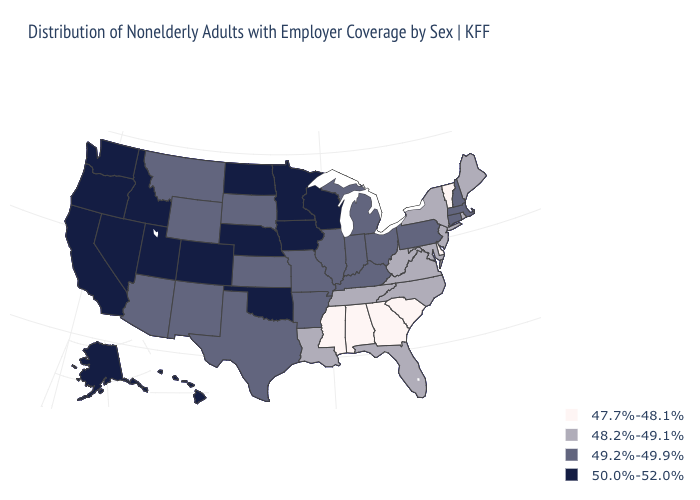Does Missouri have the lowest value in the MidWest?
Short answer required. Yes. What is the value of Minnesota?
Write a very short answer. 50.0%-52.0%. Name the states that have a value in the range 50.0%-52.0%?
Quick response, please. Alaska, California, Colorado, Hawaii, Idaho, Iowa, Minnesota, Nebraska, Nevada, North Dakota, Oklahoma, Oregon, Utah, Washington, Wisconsin. What is the value of Michigan?
Keep it brief. 49.2%-49.9%. What is the highest value in states that border Louisiana?
Be succinct. 49.2%-49.9%. Name the states that have a value in the range 47.7%-48.1%?
Keep it brief. Alabama, Delaware, Georgia, Mississippi, South Carolina, Vermont. Among the states that border Idaho , which have the lowest value?
Quick response, please. Montana, Wyoming. What is the lowest value in the South?
Answer briefly. 47.7%-48.1%. Which states have the highest value in the USA?
Short answer required. Alaska, California, Colorado, Hawaii, Idaho, Iowa, Minnesota, Nebraska, Nevada, North Dakota, Oklahoma, Oregon, Utah, Washington, Wisconsin. Name the states that have a value in the range 48.2%-49.1%?
Give a very brief answer. Florida, Louisiana, Maine, Maryland, New Jersey, New York, North Carolina, Rhode Island, Tennessee, Virginia, West Virginia. What is the highest value in the West ?
Give a very brief answer. 50.0%-52.0%. Is the legend a continuous bar?
Quick response, please. No. What is the value of Alabama?
Give a very brief answer. 47.7%-48.1%. Does the map have missing data?
Be succinct. No. 